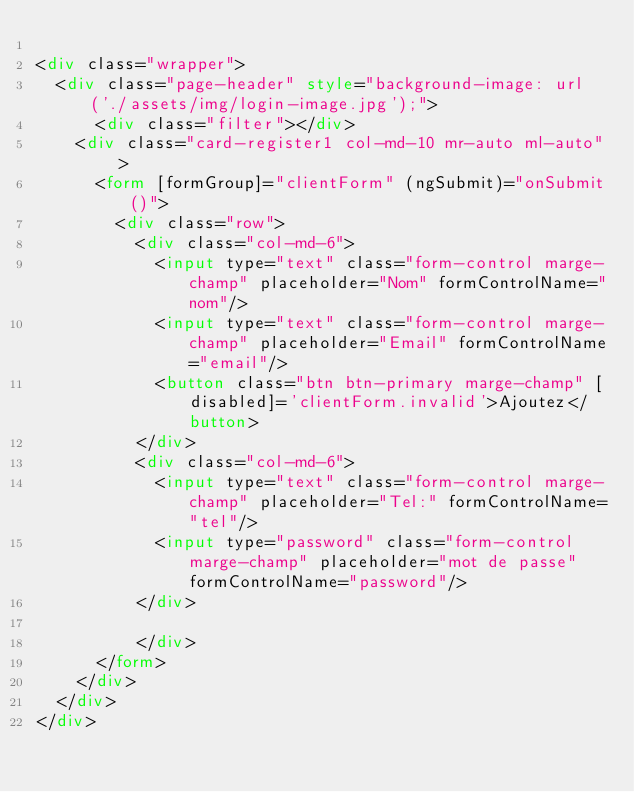Convert code to text. <code><loc_0><loc_0><loc_500><loc_500><_HTML_>
<div class="wrapper">
  <div class="page-header" style="background-image: url('./assets/img/login-image.jpg');">
      <div class="filter"></div>
    <div class="card-register1 col-md-10 mr-auto ml-auto" >
      <form [formGroup]="clientForm" (ngSubmit)="onSubmit()">
        <div class="row">
          <div class="col-md-6">
            <input type="text" class="form-control marge-champ" placeholder="Nom" formControlName="nom"/>
            <input type="text" class="form-control marge-champ" placeholder="Email" formControlName="email"/>
            <button class="btn btn-primary marge-champ" [disabled]='clientForm.invalid'>Ajoutez</button>
          </div>
          <div class="col-md-6">
            <input type="text" class="form-control marge-champ" placeholder="Tel:" formControlName="tel"/>
            <input type="password" class="form-control marge-champ" placeholder="mot de passe" formControlName="password"/>
          </div>
          
          </div>
      </form>
    </div>
  </div>
</div></code> 